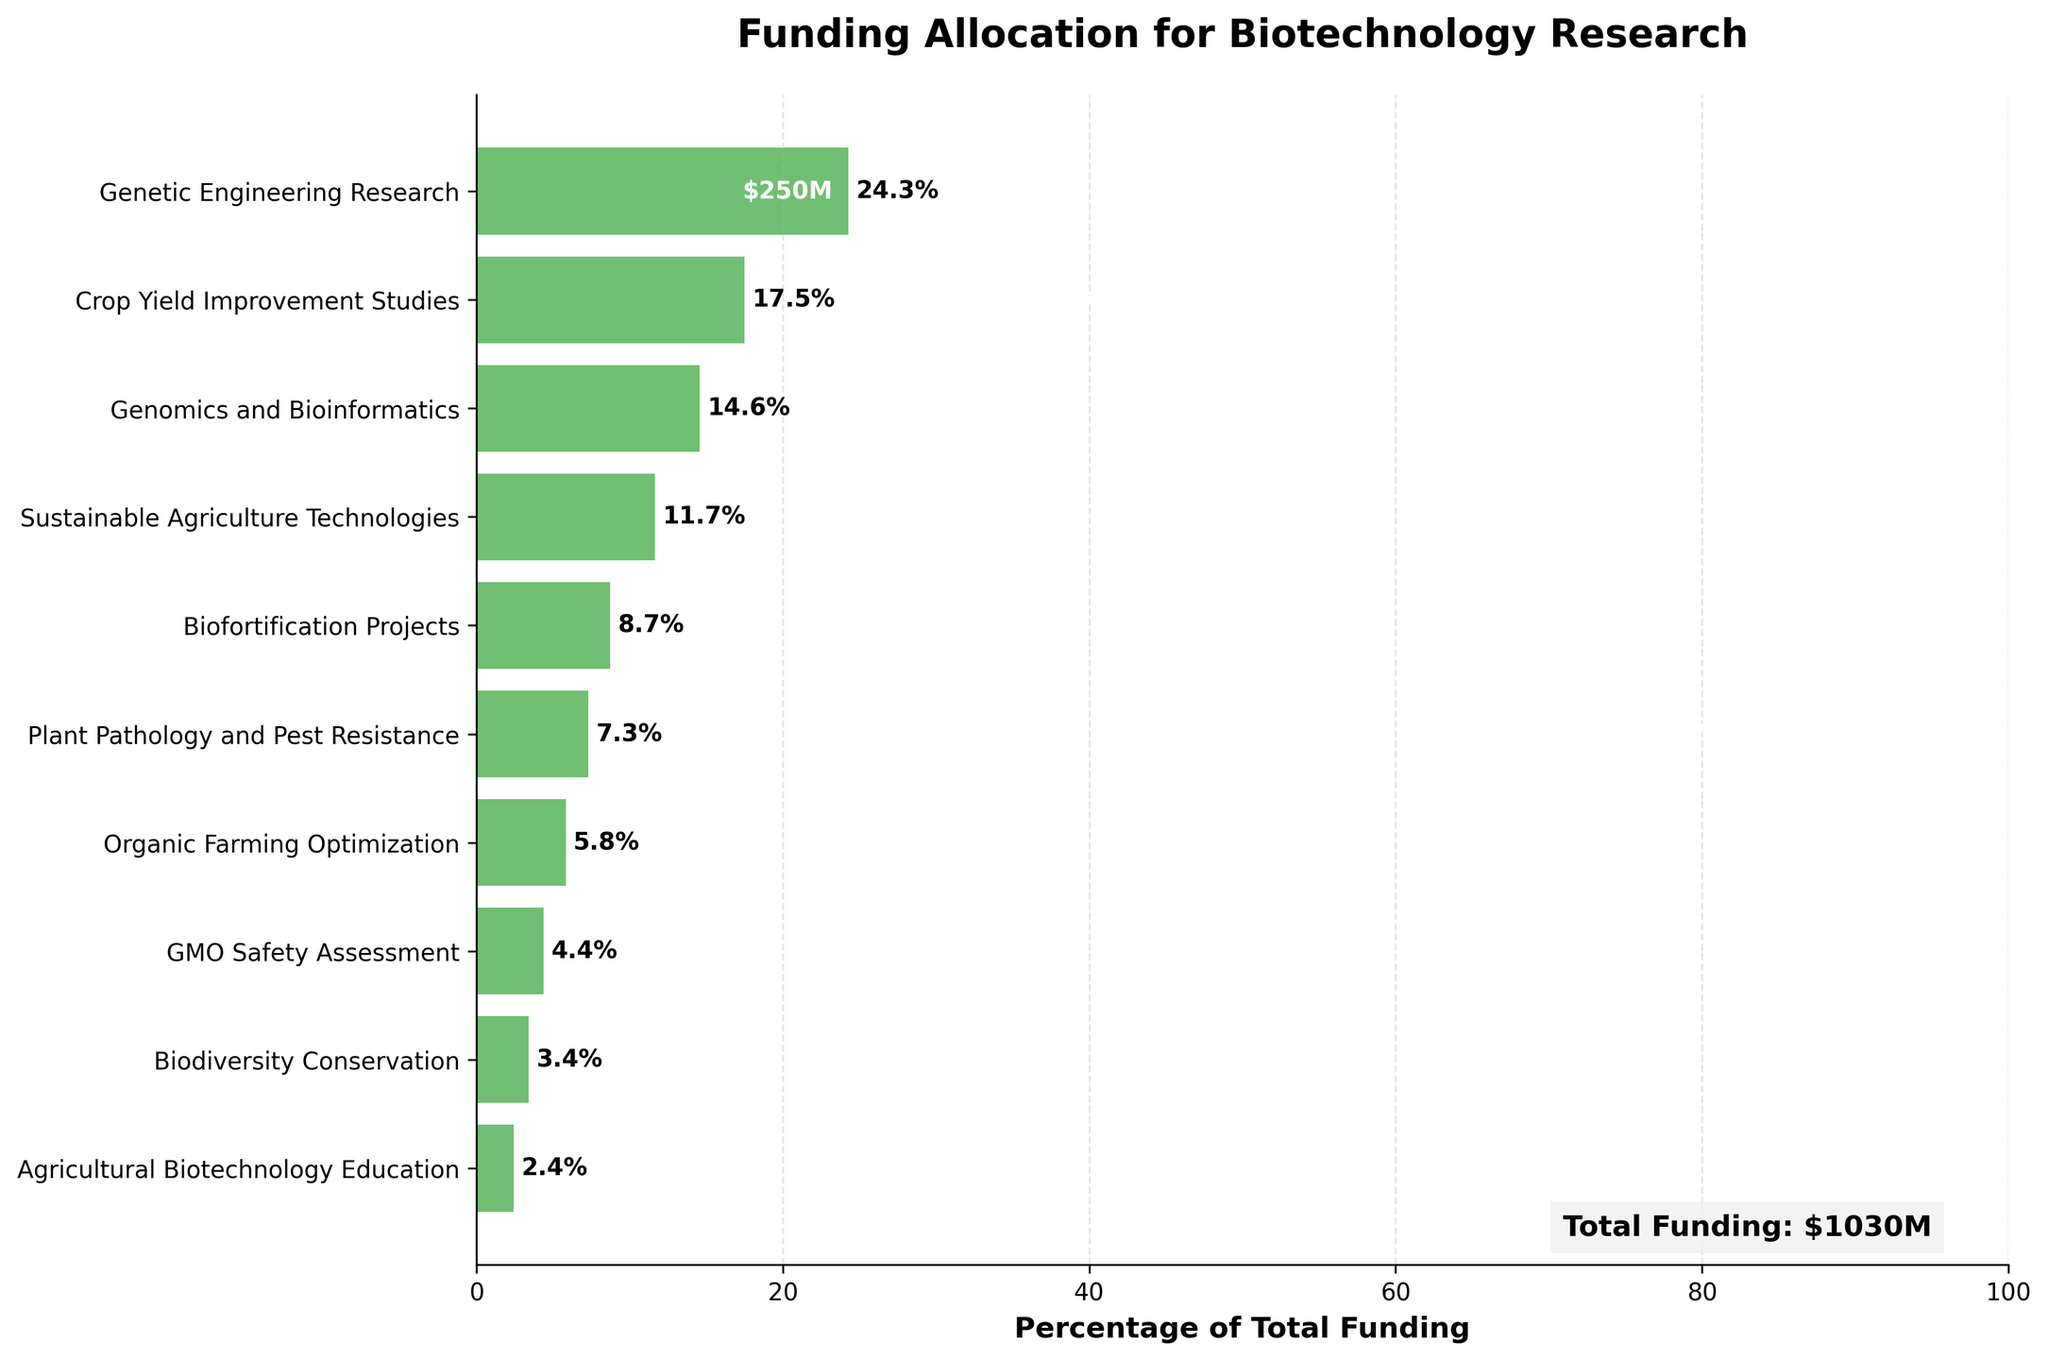What is the title of the figure? The title can be found at the top of the chart. It describes the main subject of the plot, which helps in understanding the overall context and focus of the data.
Answer: Funding Allocation for Biotechnology Research What is the total amount of funding represented in the chart? The total funding is explicitly mentioned at the bottom right corner of the chart in a text box. It sums up all the individual funding amounts.
Answer: $1030M What category receives the highest funding and how much is it? The category with the highest funding appears at the top of the funnel chart. The funding amount is shown next to the category label.
Answer: Genetic Engineering Research, $250M 